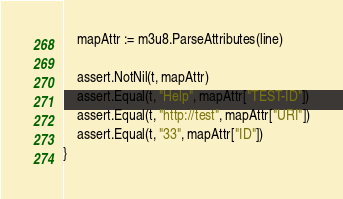Convert code to text. <code><loc_0><loc_0><loc_500><loc_500><_Go_>	mapAttr := m3u8.ParseAttributes(line)

	assert.NotNil(t, mapAttr)
	assert.Equal(t, "Help", mapAttr["TEST-ID"])
	assert.Equal(t, "http://test", mapAttr["URI"])
	assert.Equal(t, "33", mapAttr["ID"])
}
</code> 